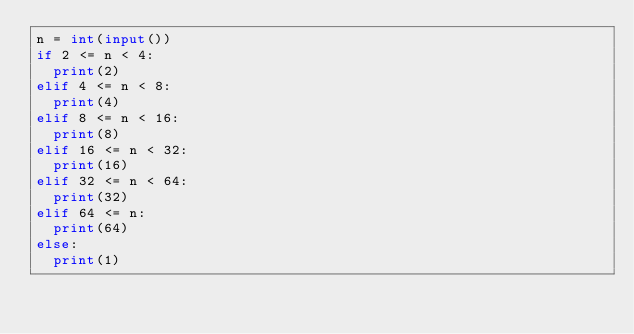<code> <loc_0><loc_0><loc_500><loc_500><_Python_>n = int(input())
if 2 <= n < 4:
  print(2)
elif 4 <= n < 8:
  print(4)
elif 8 <= n < 16:
  print(8)
elif 16 <= n < 32:
  print(16)
elif 32 <= n < 64:
  print(32)
elif 64 <= n:
  print(64)
else:
  print(1)</code> 